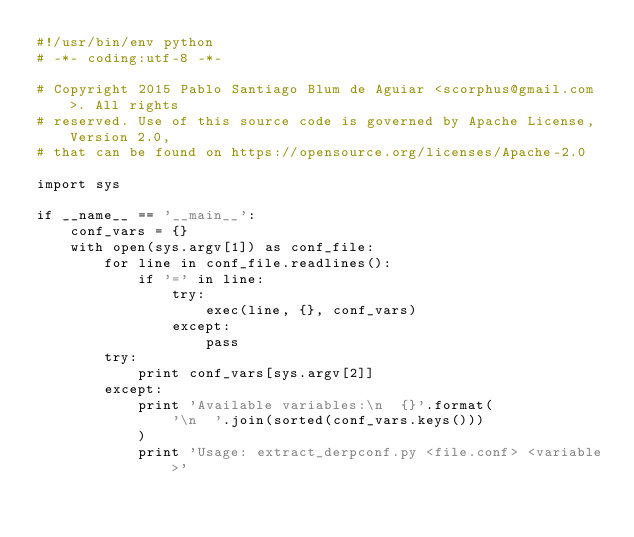Convert code to text. <code><loc_0><loc_0><loc_500><loc_500><_Python_>#!/usr/bin/env python
# -*- coding:utf-8 -*-

# Copyright 2015 Pablo Santiago Blum de Aguiar <scorphus@gmail.com>. All rights
# reserved. Use of this source code is governed by Apache License, Version 2.0,
# that can be found on https://opensource.org/licenses/Apache-2.0

import sys

if __name__ == '__main__':
    conf_vars = {}
    with open(sys.argv[1]) as conf_file:
        for line in conf_file.readlines():
            if '=' in line:
                try:
                    exec(line, {}, conf_vars)
                except:
                    pass
        try:
            print conf_vars[sys.argv[2]]
        except:
            print 'Available variables:\n  {}'.format(
                '\n  '.join(sorted(conf_vars.keys()))
            )
            print 'Usage: extract_derpconf.py <file.conf> <variable>'
</code> 